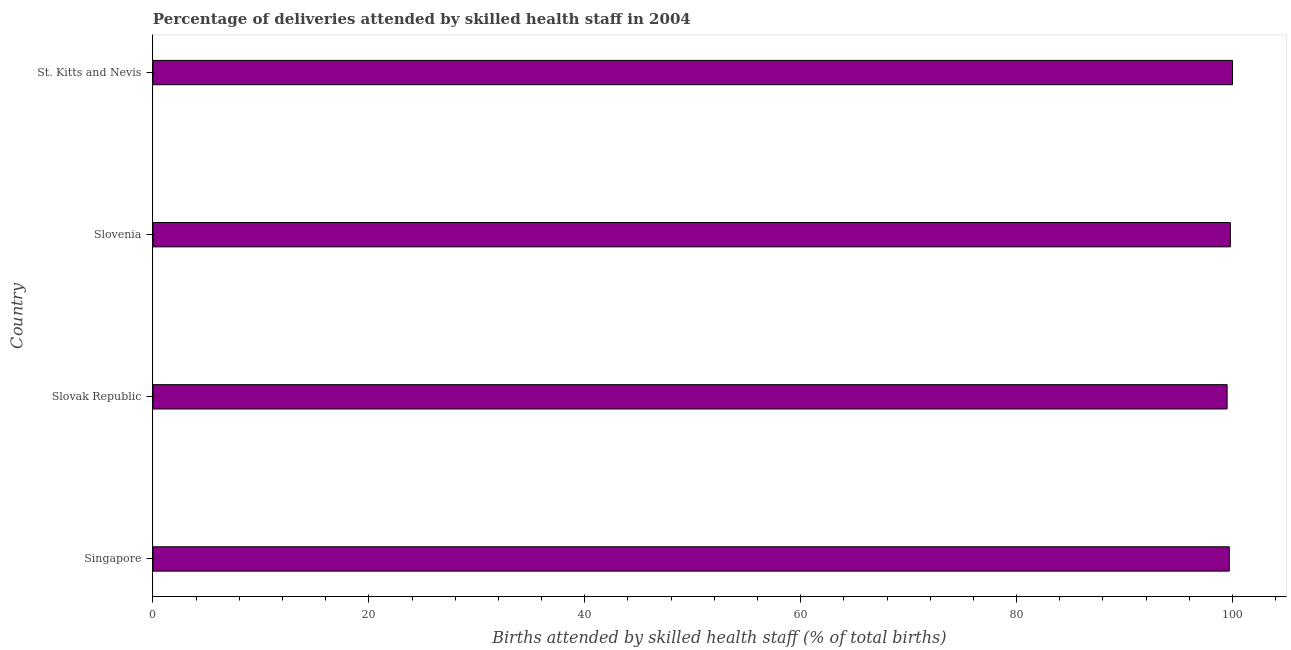Does the graph contain any zero values?
Give a very brief answer. No. What is the title of the graph?
Your answer should be compact. Percentage of deliveries attended by skilled health staff in 2004. What is the label or title of the X-axis?
Offer a terse response. Births attended by skilled health staff (% of total births). What is the number of births attended by skilled health staff in Slovak Republic?
Offer a terse response. 99.5. Across all countries, what is the minimum number of births attended by skilled health staff?
Give a very brief answer. 99.5. In which country was the number of births attended by skilled health staff maximum?
Give a very brief answer. St. Kitts and Nevis. In which country was the number of births attended by skilled health staff minimum?
Provide a short and direct response. Slovak Republic. What is the sum of the number of births attended by skilled health staff?
Give a very brief answer. 399. What is the average number of births attended by skilled health staff per country?
Offer a terse response. 99.75. What is the median number of births attended by skilled health staff?
Offer a very short reply. 99.75. What is the ratio of the number of births attended by skilled health staff in Singapore to that in St. Kitts and Nevis?
Provide a short and direct response. 1. Is the number of births attended by skilled health staff in Singapore less than that in Slovak Republic?
Make the answer very short. No. Is the difference between the number of births attended by skilled health staff in Slovenia and St. Kitts and Nevis greater than the difference between any two countries?
Your response must be concise. No. Is the sum of the number of births attended by skilled health staff in Slovak Republic and St. Kitts and Nevis greater than the maximum number of births attended by skilled health staff across all countries?
Your answer should be compact. Yes. Are all the bars in the graph horizontal?
Provide a short and direct response. Yes. How many countries are there in the graph?
Your answer should be compact. 4. What is the Births attended by skilled health staff (% of total births) of Singapore?
Your answer should be very brief. 99.7. What is the Births attended by skilled health staff (% of total births) in Slovak Republic?
Your response must be concise. 99.5. What is the Births attended by skilled health staff (% of total births) of Slovenia?
Provide a succinct answer. 99.8. What is the Births attended by skilled health staff (% of total births) in St. Kitts and Nevis?
Give a very brief answer. 100. What is the difference between the Births attended by skilled health staff (% of total births) in Singapore and Slovak Republic?
Your answer should be compact. 0.2. What is the difference between the Births attended by skilled health staff (% of total births) in Singapore and St. Kitts and Nevis?
Offer a terse response. -0.3. What is the difference between the Births attended by skilled health staff (% of total births) in Slovak Republic and Slovenia?
Give a very brief answer. -0.3. What is the ratio of the Births attended by skilled health staff (% of total births) in Singapore to that in Slovenia?
Keep it short and to the point. 1. What is the ratio of the Births attended by skilled health staff (% of total births) in Slovak Republic to that in St. Kitts and Nevis?
Your answer should be compact. 0.99. 